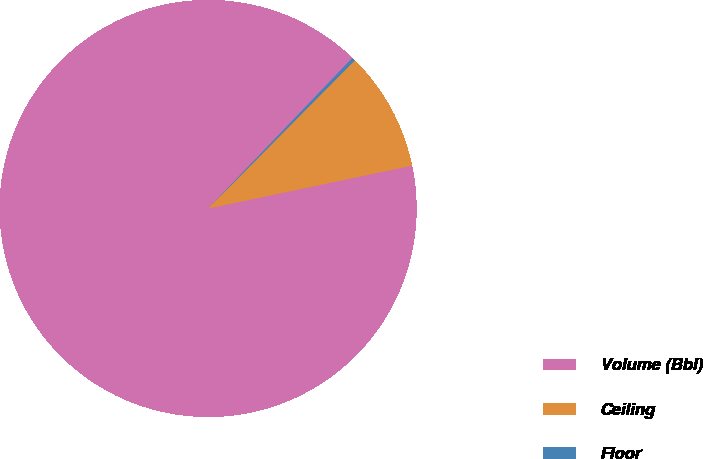<chart> <loc_0><loc_0><loc_500><loc_500><pie_chart><fcel>Volume (Bbl)<fcel>Ceiling<fcel>Floor<nl><fcel>90.46%<fcel>9.28%<fcel>0.26%<nl></chart> 